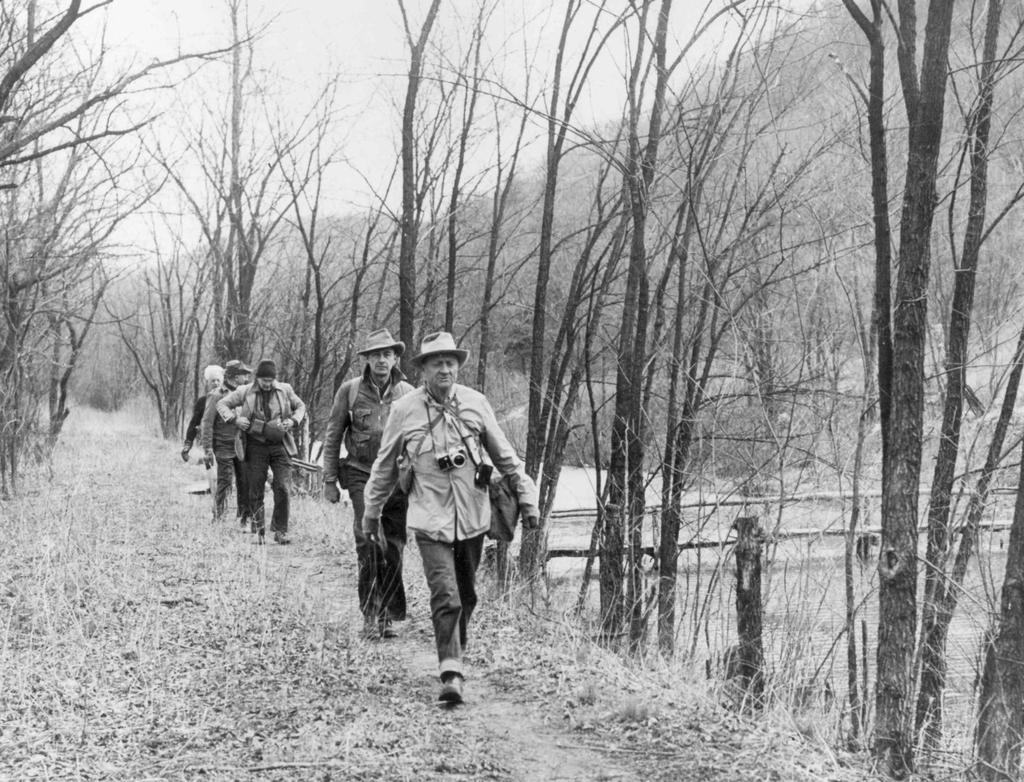What is the color scheme of the image? The image is black and white. What are the men in the image doing? The men in the image are walking on the ground. What can be seen in the background of the image? There are trees and the sky visible in the background of the image. What type of ornament is hanging from the trees in the image? There are no ornaments present in the image; it is a black and white image of men walking on the ground with trees and the sky visible in the background. 